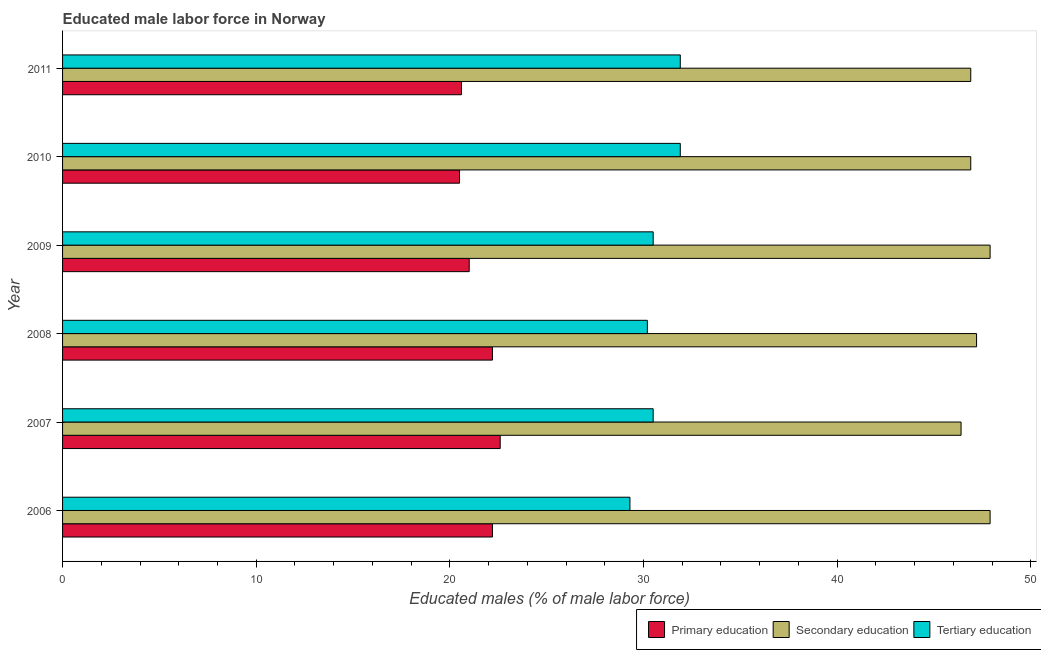How many groups of bars are there?
Your response must be concise. 6. Are the number of bars per tick equal to the number of legend labels?
Your response must be concise. Yes. Are the number of bars on each tick of the Y-axis equal?
Give a very brief answer. Yes. How many bars are there on the 4th tick from the bottom?
Offer a terse response. 3. What is the label of the 3rd group of bars from the top?
Offer a very short reply. 2009. What is the percentage of male labor force who received tertiary education in 2006?
Give a very brief answer. 29.3. Across all years, what is the maximum percentage of male labor force who received secondary education?
Offer a very short reply. 47.9. Across all years, what is the minimum percentage of male labor force who received tertiary education?
Provide a succinct answer. 29.3. What is the total percentage of male labor force who received primary education in the graph?
Make the answer very short. 129.1. What is the difference between the percentage of male labor force who received secondary education in 2006 and that in 2007?
Provide a short and direct response. 1.5. What is the difference between the percentage of male labor force who received tertiary education in 2007 and the percentage of male labor force who received secondary education in 2009?
Provide a succinct answer. -17.4. What is the average percentage of male labor force who received tertiary education per year?
Make the answer very short. 30.72. In how many years, is the percentage of male labor force who received secondary education greater than 24 %?
Your answer should be compact. 6. Is the difference between the percentage of male labor force who received primary education in 2006 and 2009 greater than the difference between the percentage of male labor force who received tertiary education in 2006 and 2009?
Offer a terse response. Yes. What is the difference between the highest and the second highest percentage of male labor force who received tertiary education?
Keep it short and to the point. 0. What is the difference between the highest and the lowest percentage of male labor force who received tertiary education?
Your answer should be compact. 2.6. In how many years, is the percentage of male labor force who received tertiary education greater than the average percentage of male labor force who received tertiary education taken over all years?
Your answer should be compact. 2. What does the 1st bar from the top in 2006 represents?
Your answer should be compact. Tertiary education. What does the 2nd bar from the bottom in 2010 represents?
Give a very brief answer. Secondary education. Is it the case that in every year, the sum of the percentage of male labor force who received primary education and percentage of male labor force who received secondary education is greater than the percentage of male labor force who received tertiary education?
Make the answer very short. Yes. How many bars are there?
Make the answer very short. 18. Are the values on the major ticks of X-axis written in scientific E-notation?
Your answer should be compact. No. Does the graph contain any zero values?
Offer a terse response. No. Does the graph contain grids?
Offer a terse response. No. How are the legend labels stacked?
Your answer should be very brief. Horizontal. What is the title of the graph?
Your answer should be compact. Educated male labor force in Norway. Does "Non-communicable diseases" appear as one of the legend labels in the graph?
Keep it short and to the point. No. What is the label or title of the X-axis?
Provide a succinct answer. Educated males (% of male labor force). What is the label or title of the Y-axis?
Give a very brief answer. Year. What is the Educated males (% of male labor force) of Primary education in 2006?
Keep it short and to the point. 22.2. What is the Educated males (% of male labor force) of Secondary education in 2006?
Your response must be concise. 47.9. What is the Educated males (% of male labor force) of Tertiary education in 2006?
Your answer should be compact. 29.3. What is the Educated males (% of male labor force) in Primary education in 2007?
Ensure brevity in your answer.  22.6. What is the Educated males (% of male labor force) in Secondary education in 2007?
Provide a short and direct response. 46.4. What is the Educated males (% of male labor force) of Tertiary education in 2007?
Ensure brevity in your answer.  30.5. What is the Educated males (% of male labor force) in Primary education in 2008?
Ensure brevity in your answer.  22.2. What is the Educated males (% of male labor force) in Secondary education in 2008?
Offer a terse response. 47.2. What is the Educated males (% of male labor force) of Tertiary education in 2008?
Your answer should be very brief. 30.2. What is the Educated males (% of male labor force) of Secondary education in 2009?
Give a very brief answer. 47.9. What is the Educated males (% of male labor force) in Tertiary education in 2009?
Your answer should be very brief. 30.5. What is the Educated males (% of male labor force) of Secondary education in 2010?
Offer a very short reply. 46.9. What is the Educated males (% of male labor force) of Tertiary education in 2010?
Ensure brevity in your answer.  31.9. What is the Educated males (% of male labor force) in Primary education in 2011?
Give a very brief answer. 20.6. What is the Educated males (% of male labor force) of Secondary education in 2011?
Offer a terse response. 46.9. What is the Educated males (% of male labor force) of Tertiary education in 2011?
Offer a terse response. 31.9. Across all years, what is the maximum Educated males (% of male labor force) of Primary education?
Make the answer very short. 22.6. Across all years, what is the maximum Educated males (% of male labor force) in Secondary education?
Your answer should be compact. 47.9. Across all years, what is the maximum Educated males (% of male labor force) in Tertiary education?
Your response must be concise. 31.9. Across all years, what is the minimum Educated males (% of male labor force) of Primary education?
Provide a short and direct response. 20.5. Across all years, what is the minimum Educated males (% of male labor force) of Secondary education?
Your response must be concise. 46.4. Across all years, what is the minimum Educated males (% of male labor force) of Tertiary education?
Your answer should be very brief. 29.3. What is the total Educated males (% of male labor force) of Primary education in the graph?
Offer a very short reply. 129.1. What is the total Educated males (% of male labor force) in Secondary education in the graph?
Offer a terse response. 283.2. What is the total Educated males (% of male labor force) of Tertiary education in the graph?
Your response must be concise. 184.3. What is the difference between the Educated males (% of male labor force) in Primary education in 2006 and that in 2007?
Your answer should be very brief. -0.4. What is the difference between the Educated males (% of male labor force) of Primary education in 2006 and that in 2008?
Your response must be concise. 0. What is the difference between the Educated males (% of male labor force) in Tertiary education in 2006 and that in 2008?
Ensure brevity in your answer.  -0.9. What is the difference between the Educated males (% of male labor force) in Secondary education in 2006 and that in 2009?
Ensure brevity in your answer.  0. What is the difference between the Educated males (% of male labor force) in Tertiary education in 2006 and that in 2009?
Keep it short and to the point. -1.2. What is the difference between the Educated males (% of male labor force) in Primary education in 2006 and that in 2010?
Your response must be concise. 1.7. What is the difference between the Educated males (% of male labor force) in Tertiary education in 2006 and that in 2010?
Ensure brevity in your answer.  -2.6. What is the difference between the Educated males (% of male labor force) of Secondary education in 2006 and that in 2011?
Ensure brevity in your answer.  1. What is the difference between the Educated males (% of male labor force) in Tertiary education in 2006 and that in 2011?
Give a very brief answer. -2.6. What is the difference between the Educated males (% of male labor force) in Primary education in 2007 and that in 2008?
Offer a terse response. 0.4. What is the difference between the Educated males (% of male labor force) in Tertiary education in 2007 and that in 2008?
Ensure brevity in your answer.  0.3. What is the difference between the Educated males (% of male labor force) in Primary education in 2007 and that in 2009?
Provide a short and direct response. 1.6. What is the difference between the Educated males (% of male labor force) in Secondary education in 2007 and that in 2009?
Your answer should be very brief. -1.5. What is the difference between the Educated males (% of male labor force) of Tertiary education in 2007 and that in 2009?
Provide a succinct answer. 0. What is the difference between the Educated males (% of male labor force) in Secondary education in 2007 and that in 2010?
Give a very brief answer. -0.5. What is the difference between the Educated males (% of male labor force) in Tertiary education in 2007 and that in 2010?
Ensure brevity in your answer.  -1.4. What is the difference between the Educated males (% of male labor force) of Primary education in 2007 and that in 2011?
Ensure brevity in your answer.  2. What is the difference between the Educated males (% of male labor force) of Secondary education in 2007 and that in 2011?
Offer a very short reply. -0.5. What is the difference between the Educated males (% of male labor force) in Tertiary education in 2007 and that in 2011?
Offer a very short reply. -1.4. What is the difference between the Educated males (% of male labor force) in Secondary education in 2008 and that in 2009?
Your answer should be very brief. -0.7. What is the difference between the Educated males (% of male labor force) of Tertiary education in 2008 and that in 2009?
Your answer should be very brief. -0.3. What is the difference between the Educated males (% of male labor force) in Primary education in 2008 and that in 2010?
Offer a terse response. 1.7. What is the difference between the Educated males (% of male labor force) in Tertiary education in 2008 and that in 2010?
Ensure brevity in your answer.  -1.7. What is the difference between the Educated males (% of male labor force) of Tertiary education in 2009 and that in 2010?
Offer a terse response. -1.4. What is the difference between the Educated males (% of male labor force) in Primary education in 2010 and that in 2011?
Keep it short and to the point. -0.1. What is the difference between the Educated males (% of male labor force) in Tertiary education in 2010 and that in 2011?
Make the answer very short. 0. What is the difference between the Educated males (% of male labor force) in Primary education in 2006 and the Educated males (% of male labor force) in Secondary education in 2007?
Provide a succinct answer. -24.2. What is the difference between the Educated males (% of male labor force) of Secondary education in 2006 and the Educated males (% of male labor force) of Tertiary education in 2008?
Provide a succinct answer. 17.7. What is the difference between the Educated males (% of male labor force) of Primary education in 2006 and the Educated males (% of male labor force) of Secondary education in 2009?
Offer a terse response. -25.7. What is the difference between the Educated males (% of male labor force) of Primary education in 2006 and the Educated males (% of male labor force) of Secondary education in 2010?
Your answer should be very brief. -24.7. What is the difference between the Educated males (% of male labor force) in Secondary education in 2006 and the Educated males (% of male labor force) in Tertiary education in 2010?
Ensure brevity in your answer.  16. What is the difference between the Educated males (% of male labor force) of Primary education in 2006 and the Educated males (% of male labor force) of Secondary education in 2011?
Provide a short and direct response. -24.7. What is the difference between the Educated males (% of male labor force) of Primary education in 2007 and the Educated males (% of male labor force) of Secondary education in 2008?
Your response must be concise. -24.6. What is the difference between the Educated males (% of male labor force) in Primary education in 2007 and the Educated males (% of male labor force) in Tertiary education in 2008?
Offer a terse response. -7.6. What is the difference between the Educated males (% of male labor force) in Secondary education in 2007 and the Educated males (% of male labor force) in Tertiary education in 2008?
Your response must be concise. 16.2. What is the difference between the Educated males (% of male labor force) in Primary education in 2007 and the Educated males (% of male labor force) in Secondary education in 2009?
Give a very brief answer. -25.3. What is the difference between the Educated males (% of male labor force) in Primary education in 2007 and the Educated males (% of male labor force) in Secondary education in 2010?
Ensure brevity in your answer.  -24.3. What is the difference between the Educated males (% of male labor force) in Primary education in 2007 and the Educated males (% of male labor force) in Tertiary education in 2010?
Keep it short and to the point. -9.3. What is the difference between the Educated males (% of male labor force) in Primary education in 2007 and the Educated males (% of male labor force) in Secondary education in 2011?
Make the answer very short. -24.3. What is the difference between the Educated males (% of male labor force) in Secondary education in 2007 and the Educated males (% of male labor force) in Tertiary education in 2011?
Offer a very short reply. 14.5. What is the difference between the Educated males (% of male labor force) in Primary education in 2008 and the Educated males (% of male labor force) in Secondary education in 2009?
Ensure brevity in your answer.  -25.7. What is the difference between the Educated males (% of male labor force) in Primary education in 2008 and the Educated males (% of male labor force) in Tertiary education in 2009?
Your answer should be compact. -8.3. What is the difference between the Educated males (% of male labor force) of Primary education in 2008 and the Educated males (% of male labor force) of Secondary education in 2010?
Provide a succinct answer. -24.7. What is the difference between the Educated males (% of male labor force) in Primary education in 2008 and the Educated males (% of male labor force) in Secondary education in 2011?
Your answer should be compact. -24.7. What is the difference between the Educated males (% of male labor force) of Primary education in 2008 and the Educated males (% of male labor force) of Tertiary education in 2011?
Provide a short and direct response. -9.7. What is the difference between the Educated males (% of male labor force) of Primary education in 2009 and the Educated males (% of male labor force) of Secondary education in 2010?
Offer a terse response. -25.9. What is the difference between the Educated males (% of male labor force) of Primary education in 2009 and the Educated males (% of male labor force) of Tertiary education in 2010?
Provide a succinct answer. -10.9. What is the difference between the Educated males (% of male labor force) of Secondary education in 2009 and the Educated males (% of male labor force) of Tertiary education in 2010?
Ensure brevity in your answer.  16. What is the difference between the Educated males (% of male labor force) in Primary education in 2009 and the Educated males (% of male labor force) in Secondary education in 2011?
Your answer should be very brief. -25.9. What is the difference between the Educated males (% of male labor force) in Primary education in 2010 and the Educated males (% of male labor force) in Secondary education in 2011?
Keep it short and to the point. -26.4. What is the difference between the Educated males (% of male labor force) of Primary education in 2010 and the Educated males (% of male labor force) of Tertiary education in 2011?
Give a very brief answer. -11.4. What is the average Educated males (% of male labor force) of Primary education per year?
Provide a short and direct response. 21.52. What is the average Educated males (% of male labor force) in Secondary education per year?
Ensure brevity in your answer.  47.2. What is the average Educated males (% of male labor force) in Tertiary education per year?
Your answer should be compact. 30.72. In the year 2006, what is the difference between the Educated males (% of male labor force) in Primary education and Educated males (% of male labor force) in Secondary education?
Your response must be concise. -25.7. In the year 2007, what is the difference between the Educated males (% of male labor force) in Primary education and Educated males (% of male labor force) in Secondary education?
Make the answer very short. -23.8. In the year 2007, what is the difference between the Educated males (% of male labor force) of Secondary education and Educated males (% of male labor force) of Tertiary education?
Give a very brief answer. 15.9. In the year 2008, what is the difference between the Educated males (% of male labor force) in Primary education and Educated males (% of male labor force) in Secondary education?
Ensure brevity in your answer.  -25. In the year 2008, what is the difference between the Educated males (% of male labor force) in Primary education and Educated males (% of male labor force) in Tertiary education?
Give a very brief answer. -8. In the year 2009, what is the difference between the Educated males (% of male labor force) in Primary education and Educated males (% of male labor force) in Secondary education?
Your answer should be very brief. -26.9. In the year 2010, what is the difference between the Educated males (% of male labor force) of Primary education and Educated males (% of male labor force) of Secondary education?
Keep it short and to the point. -26.4. In the year 2011, what is the difference between the Educated males (% of male labor force) in Primary education and Educated males (% of male labor force) in Secondary education?
Your response must be concise. -26.3. In the year 2011, what is the difference between the Educated males (% of male labor force) of Primary education and Educated males (% of male labor force) of Tertiary education?
Make the answer very short. -11.3. What is the ratio of the Educated males (% of male labor force) of Primary education in 2006 to that in 2007?
Make the answer very short. 0.98. What is the ratio of the Educated males (% of male labor force) in Secondary education in 2006 to that in 2007?
Give a very brief answer. 1.03. What is the ratio of the Educated males (% of male labor force) of Tertiary education in 2006 to that in 2007?
Your answer should be compact. 0.96. What is the ratio of the Educated males (% of male labor force) in Primary education in 2006 to that in 2008?
Your response must be concise. 1. What is the ratio of the Educated males (% of male labor force) of Secondary education in 2006 to that in 2008?
Provide a short and direct response. 1.01. What is the ratio of the Educated males (% of male labor force) in Tertiary education in 2006 to that in 2008?
Offer a very short reply. 0.97. What is the ratio of the Educated males (% of male labor force) of Primary education in 2006 to that in 2009?
Give a very brief answer. 1.06. What is the ratio of the Educated males (% of male labor force) of Tertiary education in 2006 to that in 2009?
Offer a very short reply. 0.96. What is the ratio of the Educated males (% of male labor force) in Primary education in 2006 to that in 2010?
Provide a succinct answer. 1.08. What is the ratio of the Educated males (% of male labor force) in Secondary education in 2006 to that in 2010?
Offer a terse response. 1.02. What is the ratio of the Educated males (% of male labor force) in Tertiary education in 2006 to that in 2010?
Give a very brief answer. 0.92. What is the ratio of the Educated males (% of male labor force) of Primary education in 2006 to that in 2011?
Provide a short and direct response. 1.08. What is the ratio of the Educated males (% of male labor force) of Secondary education in 2006 to that in 2011?
Provide a succinct answer. 1.02. What is the ratio of the Educated males (% of male labor force) of Tertiary education in 2006 to that in 2011?
Your answer should be very brief. 0.92. What is the ratio of the Educated males (% of male labor force) in Secondary education in 2007 to that in 2008?
Offer a terse response. 0.98. What is the ratio of the Educated males (% of male labor force) in Tertiary education in 2007 to that in 2008?
Make the answer very short. 1.01. What is the ratio of the Educated males (% of male labor force) in Primary education in 2007 to that in 2009?
Make the answer very short. 1.08. What is the ratio of the Educated males (% of male labor force) of Secondary education in 2007 to that in 2009?
Your answer should be very brief. 0.97. What is the ratio of the Educated males (% of male labor force) of Primary education in 2007 to that in 2010?
Ensure brevity in your answer.  1.1. What is the ratio of the Educated males (% of male labor force) in Secondary education in 2007 to that in 2010?
Make the answer very short. 0.99. What is the ratio of the Educated males (% of male labor force) of Tertiary education in 2007 to that in 2010?
Provide a succinct answer. 0.96. What is the ratio of the Educated males (% of male labor force) in Primary education in 2007 to that in 2011?
Provide a succinct answer. 1.1. What is the ratio of the Educated males (% of male labor force) in Secondary education in 2007 to that in 2011?
Provide a short and direct response. 0.99. What is the ratio of the Educated males (% of male labor force) of Tertiary education in 2007 to that in 2011?
Make the answer very short. 0.96. What is the ratio of the Educated males (% of male labor force) of Primary education in 2008 to that in 2009?
Give a very brief answer. 1.06. What is the ratio of the Educated males (% of male labor force) of Secondary education in 2008 to that in 2009?
Provide a short and direct response. 0.99. What is the ratio of the Educated males (% of male labor force) of Tertiary education in 2008 to that in 2009?
Your answer should be very brief. 0.99. What is the ratio of the Educated males (% of male labor force) in Primary education in 2008 to that in 2010?
Your answer should be very brief. 1.08. What is the ratio of the Educated males (% of male labor force) in Secondary education in 2008 to that in 2010?
Keep it short and to the point. 1.01. What is the ratio of the Educated males (% of male labor force) in Tertiary education in 2008 to that in 2010?
Give a very brief answer. 0.95. What is the ratio of the Educated males (% of male labor force) in Primary education in 2008 to that in 2011?
Your answer should be compact. 1.08. What is the ratio of the Educated males (% of male labor force) in Secondary education in 2008 to that in 2011?
Offer a very short reply. 1.01. What is the ratio of the Educated males (% of male labor force) in Tertiary education in 2008 to that in 2011?
Ensure brevity in your answer.  0.95. What is the ratio of the Educated males (% of male labor force) of Primary education in 2009 to that in 2010?
Your answer should be very brief. 1.02. What is the ratio of the Educated males (% of male labor force) in Secondary education in 2009 to that in 2010?
Give a very brief answer. 1.02. What is the ratio of the Educated males (% of male labor force) of Tertiary education in 2009 to that in 2010?
Your answer should be compact. 0.96. What is the ratio of the Educated males (% of male labor force) of Primary education in 2009 to that in 2011?
Your answer should be compact. 1.02. What is the ratio of the Educated males (% of male labor force) of Secondary education in 2009 to that in 2011?
Your answer should be compact. 1.02. What is the ratio of the Educated males (% of male labor force) in Tertiary education in 2009 to that in 2011?
Provide a succinct answer. 0.96. What is the ratio of the Educated males (% of male labor force) of Primary education in 2010 to that in 2011?
Keep it short and to the point. 1. What is the difference between the highest and the second highest Educated males (% of male labor force) in Primary education?
Your answer should be very brief. 0.4. What is the difference between the highest and the second highest Educated males (% of male labor force) of Secondary education?
Provide a succinct answer. 0. What is the difference between the highest and the lowest Educated males (% of male labor force) in Primary education?
Your response must be concise. 2.1. What is the difference between the highest and the lowest Educated males (% of male labor force) in Secondary education?
Make the answer very short. 1.5. What is the difference between the highest and the lowest Educated males (% of male labor force) in Tertiary education?
Your response must be concise. 2.6. 